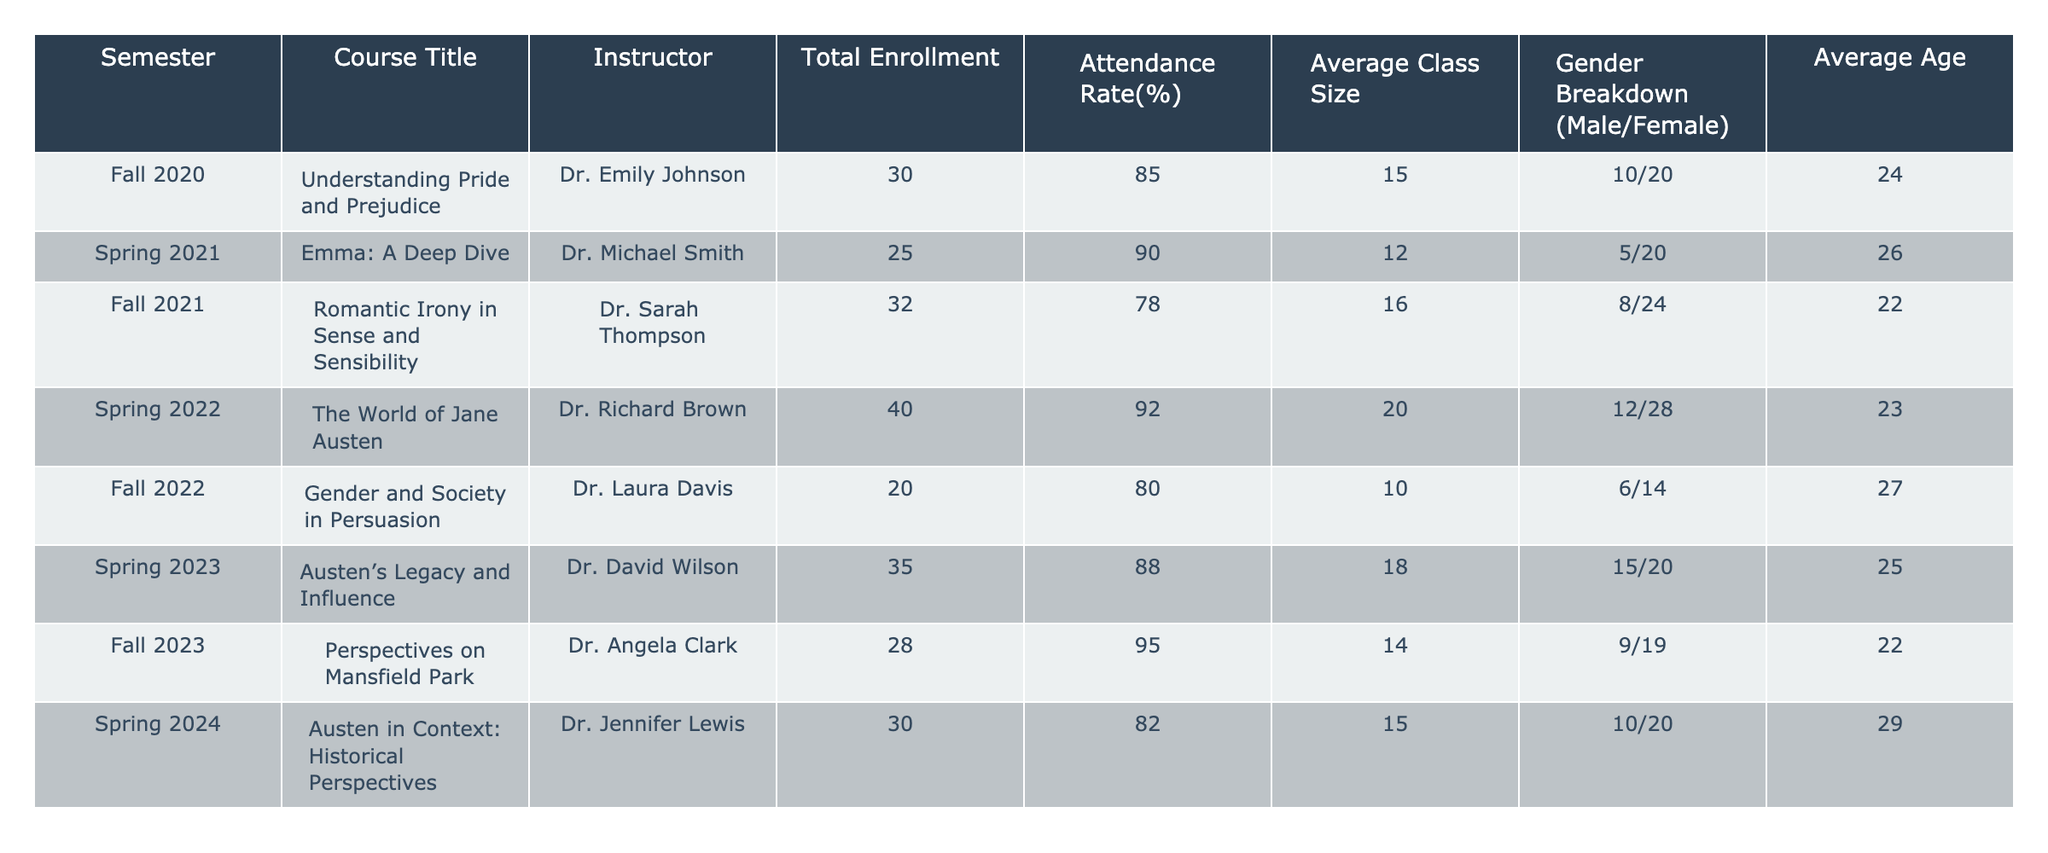What is the attendance rate for the course "Understanding Pride and Prejudice"? The table states that the attendance rate for "Understanding Pride and Prejudice" in Fall 2020 is 85%.
Answer: 85% Which course had the highest average class size? By comparing the "Average Class Size" column, the course titled "The World of Jane Austen" in Spring 2022 had the highest average class size of 20.
Answer: 20 Was the gender breakdown in the course "Emma: A Deep Dive" equal? For "Emma: A Deep Dive," the gender breakdown is 5 males and 20 females, indicating that the gender distribution was not equal.
Answer: No What is the total enrollment across all semesters for the courses listed? The total enrollment can be calculated by adding the "Total Enrollment" figures from the table: 30 + 25 + 32 + 40 + 20 + 35 + 28 + 30 =  230.
Answer: 230 Which course had the lowest attendance rate and what is that percentage? The course "Romantic Irony in Sense and Sensibility" had the lowest attendance rate of 78%, as observed in the table.
Answer: 78% How many more females than males were enrolled in the course "Perspectives on Mansfield Park"? The gender breakdown for "Perspectives on Mansfield Park" is 9 males and 19 females. The difference is 19 - 9 = 10 more females than males.
Answer: 10 What is the average age of students attending the "Austen’s Legacy and Influence" course? The table lists the average age for "Austen's Legacy and Influence" as 25.
Answer: 25 Which semester had the highest enrollment, and what was the number? The semester with the highest enrollment was Spring 2022 with an enrollment of 40 students in "The World of Jane Austen."
Answer: 40 If we consider only the courses in Fall semesters, what is the average attendance rate? The attendance rates for the fall courses are 85%, 78%, 80%, and 95%. The average is (85 + 78 + 80 + 95) / 4 = 84.5%.
Answer: 84.5% How many total courses were taught by Dr. Michael Smith? Referring to the table, Dr. Michael Smith taught only one course, "Emma: A Deep Dive" in Spring 2021.
Answer: 1 